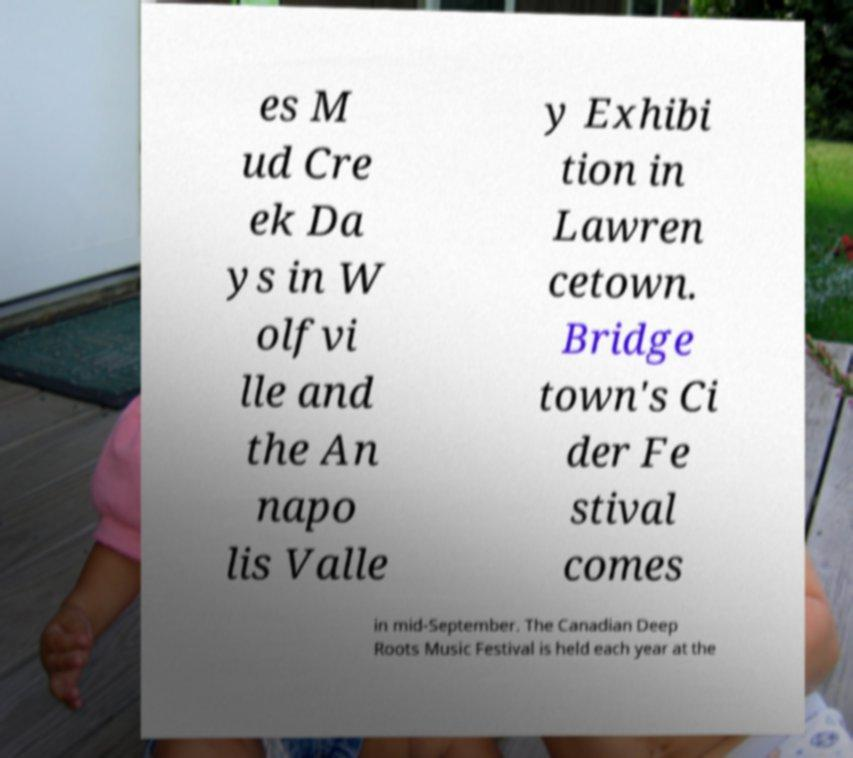Please read and relay the text visible in this image. What does it say? es M ud Cre ek Da ys in W olfvi lle and the An napo lis Valle y Exhibi tion in Lawren cetown. Bridge town's Ci der Fe stival comes in mid-September. The Canadian Deep Roots Music Festival is held each year at the 